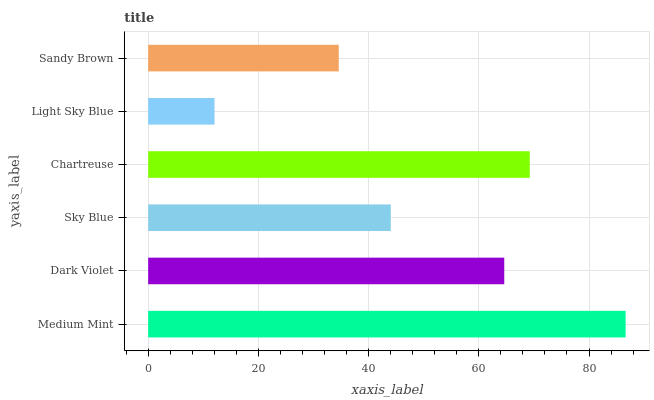Is Light Sky Blue the minimum?
Answer yes or no. Yes. Is Medium Mint the maximum?
Answer yes or no. Yes. Is Dark Violet the minimum?
Answer yes or no. No. Is Dark Violet the maximum?
Answer yes or no. No. Is Medium Mint greater than Dark Violet?
Answer yes or no. Yes. Is Dark Violet less than Medium Mint?
Answer yes or no. Yes. Is Dark Violet greater than Medium Mint?
Answer yes or no. No. Is Medium Mint less than Dark Violet?
Answer yes or no. No. Is Dark Violet the high median?
Answer yes or no. Yes. Is Sky Blue the low median?
Answer yes or no. Yes. Is Sky Blue the high median?
Answer yes or no. No. Is Medium Mint the low median?
Answer yes or no. No. 